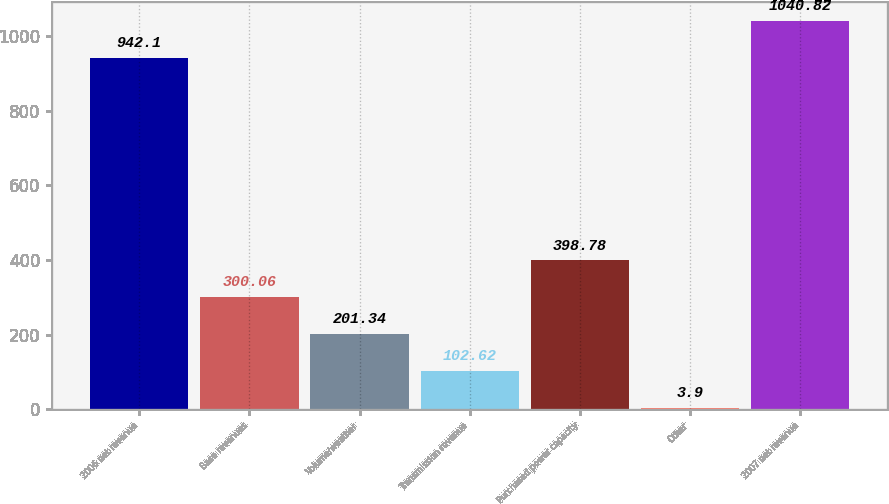Convert chart to OTSL. <chart><loc_0><loc_0><loc_500><loc_500><bar_chart><fcel>2006 net revenue<fcel>Base revenues<fcel>Volume/weather<fcel>Transmission revenue<fcel>Purchased power capacity<fcel>Other<fcel>2007 net revenue<nl><fcel>942.1<fcel>300.06<fcel>201.34<fcel>102.62<fcel>398.78<fcel>3.9<fcel>1040.82<nl></chart> 